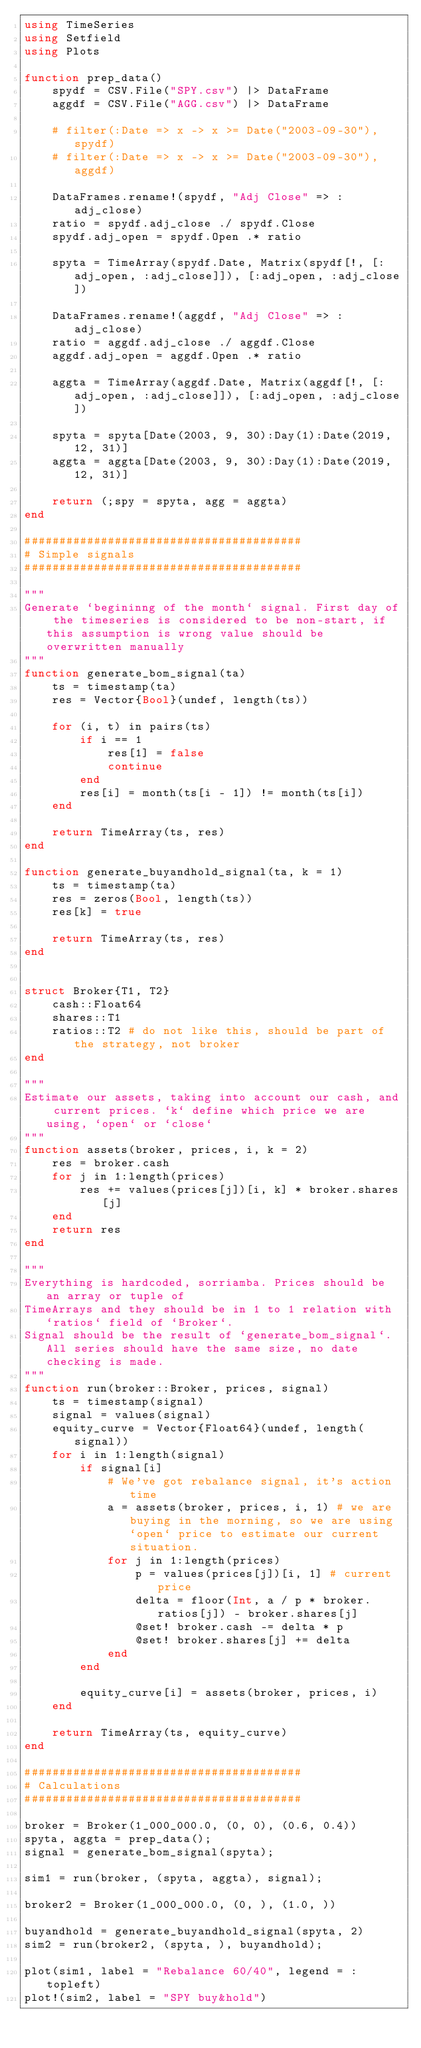Convert code to text. <code><loc_0><loc_0><loc_500><loc_500><_Julia_>using TimeSeries
using Setfield
using Plots

function prep_data()
    spydf = CSV.File("SPY.csv") |> DataFrame
    aggdf = CSV.File("AGG.csv") |> DataFrame

    # filter(:Date => x -> x >= Date("2003-09-30"), spydf)
    # filter(:Date => x -> x >= Date("2003-09-30"), aggdf)

    DataFrames.rename!(spydf, "Adj Close" => :adj_close)
    ratio = spydf.adj_close ./ spydf.Close
    spydf.adj_open = spydf.Open .* ratio

    spyta = TimeArray(spydf.Date, Matrix(spydf[!, [:adj_open, :adj_close]]), [:adj_open, :adj_close])

    DataFrames.rename!(aggdf, "Adj Close" => :adj_close)
    ratio = aggdf.adj_close ./ aggdf.Close
    aggdf.adj_open = aggdf.Open .* ratio

    aggta = TimeArray(aggdf.Date, Matrix(aggdf[!, [:adj_open, :adj_close]]), [:adj_open, :adj_close])

    spyta = spyta[Date(2003, 9, 30):Day(1):Date(2019, 12, 31)]
    aggta = aggta[Date(2003, 9, 30):Day(1):Date(2019, 12, 31)]

    return (;spy = spyta, agg = aggta)
end

########################################
# Simple signals
########################################

"""
Generate `begininng of the month` signal. First day of the timeseries is considered to be non-start, if this assumption is wrong value should be overwritten manually
"""
function generate_bom_signal(ta)
    ts = timestamp(ta)
    res = Vector{Bool}(undef, length(ts))

    for (i, t) in pairs(ts)
        if i == 1 
            res[1] = false
            continue
        end
        res[i] = month(ts[i - 1]) != month(ts[i])
    end

    return TimeArray(ts, res)
end

function generate_buyandhold_signal(ta, k = 1)
    ts = timestamp(ta)
    res = zeros(Bool, length(ts))
    res[k] = true

    return TimeArray(ts, res)
end


struct Broker{T1, T2}
    cash::Float64
    shares::T1
    ratios::T2 # do not like this, should be part of the strategy, not broker
end

"""
Estimate our assets, taking into account our cash, and current prices. `k` define which price we are using, `open` or `close`
"""
function assets(broker, prices, i, k = 2)
    res = broker.cash
    for j in 1:length(prices)
        res += values(prices[j])[i, k] * broker.shares[j]
    end
    return res
end

"""
Everything is hardcoded, sorriamba. Prices should be an array or tuple of 
TimeArrays and they should be in 1 to 1 relation with `ratios` field of `Broker`. 
Signal should be the result of `generate_bom_signal`. All series should have the same size, no date checking is made.
"""
function run(broker::Broker, prices, signal)
    ts = timestamp(signal)
    signal = values(signal)
    equity_curve = Vector{Float64}(undef, length(signal))
    for i in 1:length(signal)
        if signal[i]
            # We've got rebalance signal, it's action time
            a = assets(broker, prices, i, 1) # we are buying in the morning, so we are using `open` price to estimate our current situation.
            for j in 1:length(prices)
                p = values(prices[j])[i, 1] # current price
                delta = floor(Int, a / p * broker.ratios[j]) - broker.shares[j]
                @set! broker.cash -= delta * p
                @set! broker.shares[j] += delta
            end
        end

        equity_curve[i] = assets(broker, prices, i)
    end

    return TimeArray(ts, equity_curve)
end

########################################
# Calculations
########################################

broker = Broker(1_000_000.0, (0, 0), (0.6, 0.4))
spyta, aggta = prep_data();
signal = generate_bom_signal(spyta);

sim1 = run(broker, (spyta, aggta), signal);

broker2 = Broker(1_000_000.0, (0, ), (1.0, ))

buyandhold = generate_buyandhold_signal(spyta, 2)
sim2 = run(broker2, (spyta, ), buyandhold);

plot(sim1, label = "Rebalance 60/40", legend = :topleft)
plot!(sim2, label = "SPY buy&hold")
</code> 